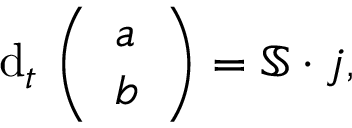<formula> <loc_0><loc_0><loc_500><loc_500>d _ { t } \, \left ( \begin{array} { l } { a } \\ { b } \end{array} \right ) = \mathbb { S } \cdot j ,</formula> 